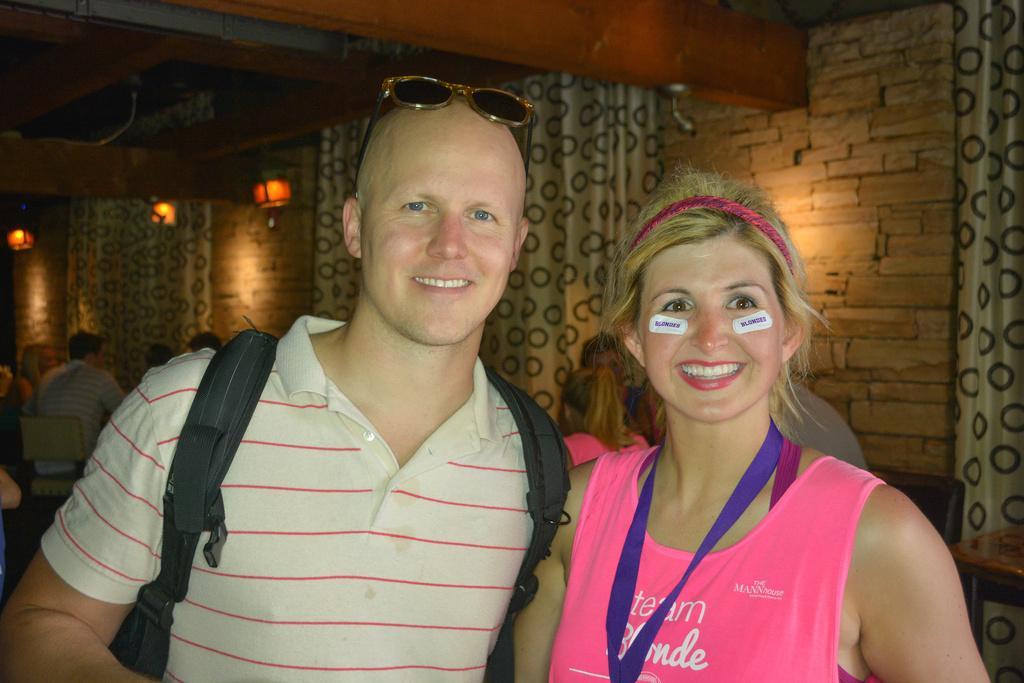In one or two sentences, can you explain what this image depicts? In this picture we can see few people, in the middle of the image we can see a man and woman, they both are smiling and he is carrying a bag, behind them we can see few curtains and lights. 